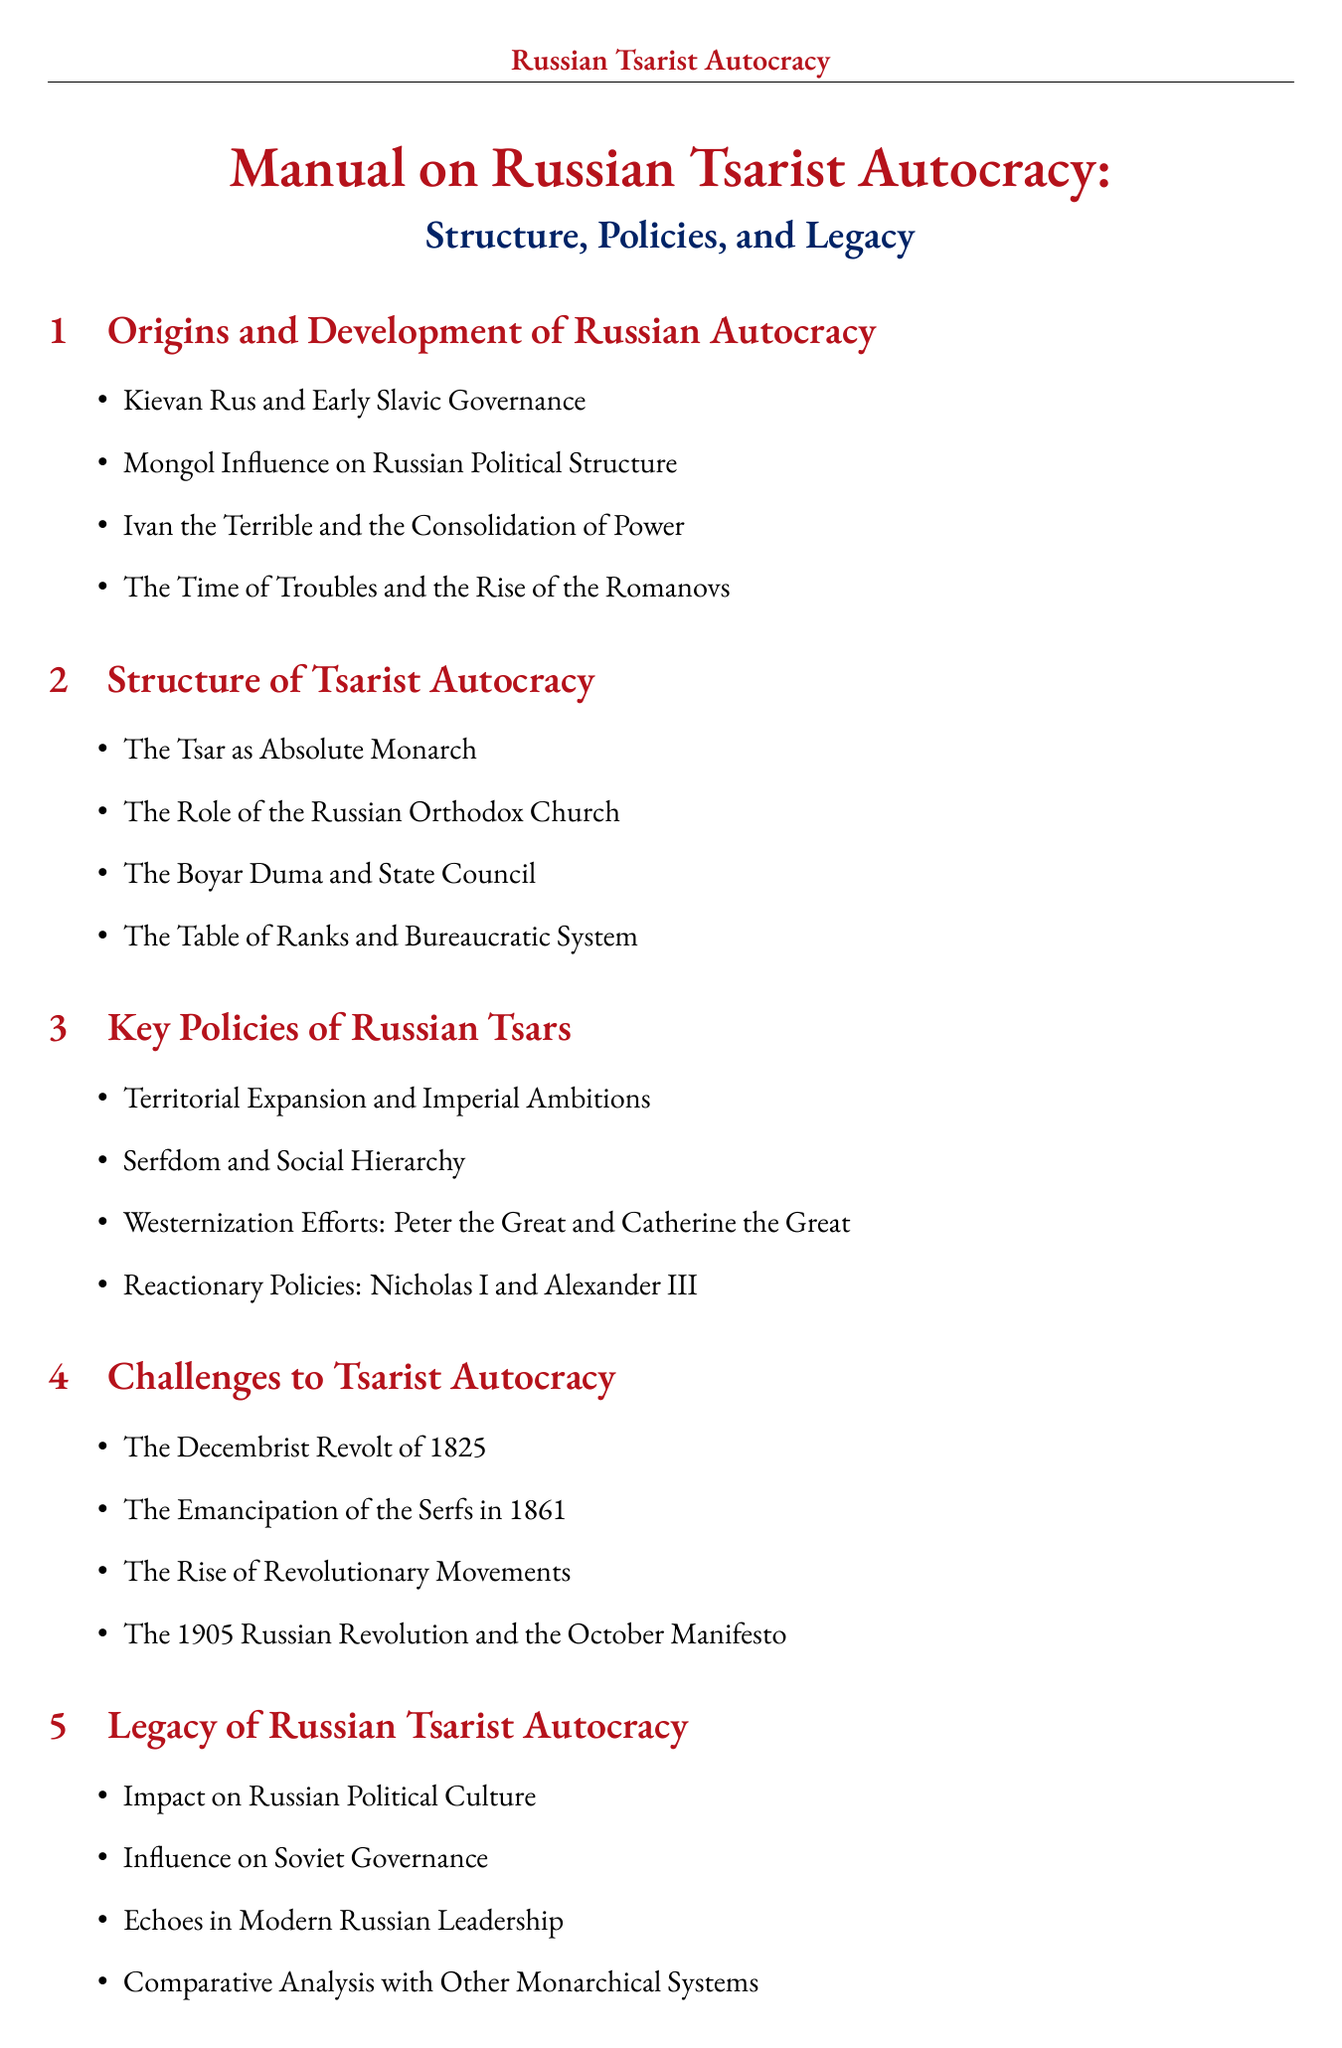What was the first Tsar of Russia? Ivan IV, also known as Ivan the Terrible, is noted as the first Tsar of Russia in the document.
Answer: Ivan IV (The Terrible) Who modernized Russia in the 18th century? Peter I, referred to as Peter the Great in the document, is noted for modernizing Russia in the 18th century.
Answer: Peter I (The Great) What year was the Emancipation of the Serfs? The document states that the Emancipation of the Serfs occurred in 1861.
Answer: 1861 What policy involved mass repression during Ivan the Terrible's reign? The document mentions the Oprichnina, which was a policy of mass repression during Ivan's reign.
Answer: Oprichnina Name one primary source mentioned in the document. The document lists several primary sources, one of which is the Law Code (Sudebnik) of 1550.
Answer: The Law Code (Sudebnik) of 1550 What was a significant outcome of Nicholas II's reign? The document states that Nicholas II's reign led to the fall of the Romanov dynasty.
Answer: Fall of the Romanov dynasty Which Tsar implemented local self-government bodies known as Zemstvo? The document attributes the introduction of Zemstvo to Alexander II.
Answer: Alexander II What term describes a system where one person has absolute power? The term used in the document for this system is Autocracy.
Answer: Autocracy What was Catherine the Great's policy towards non-Russian peoples? The document refers to this policy as Russification.
Answer: Russification Which book is recommended reading on the Russian Empire? The document mentions "The Russian Empire 1801-1917" by Hugh Seton-Watson as recommended reading.
Answer: The Russian Empire 1801-1917 